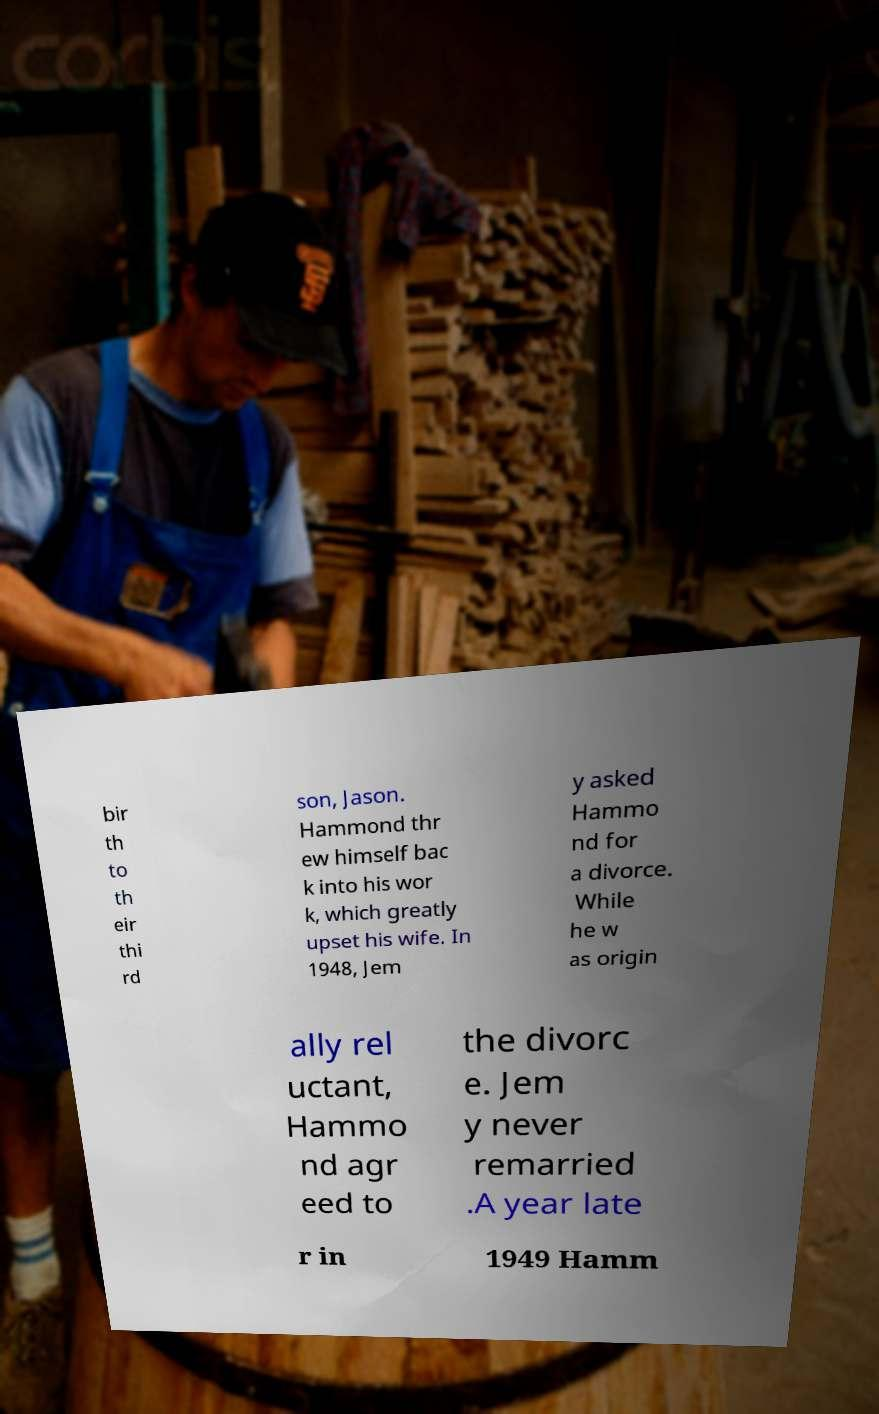Could you extract and type out the text from this image? bir th to th eir thi rd son, Jason. Hammond thr ew himself bac k into his wor k, which greatly upset his wife. In 1948, Jem y asked Hammo nd for a divorce. While he w as origin ally rel uctant, Hammo nd agr eed to the divorc e. Jem y never remarried .A year late r in 1949 Hamm 